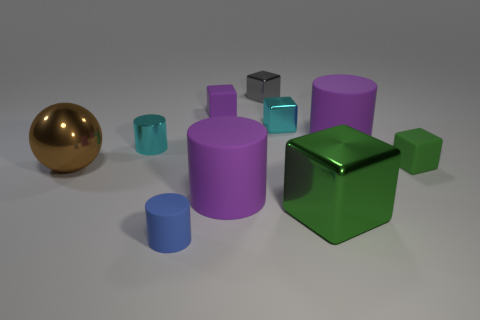How many rubber objects are purple cylinders or green blocks?
Ensure brevity in your answer.  3. Is the number of tiny cylinders in front of the tiny blue rubber object less than the number of purple matte things behind the tiny cyan metal block?
Your answer should be very brief. Yes. Is there a small object on the left side of the purple matte thing that is behind the big purple thing on the right side of the green shiny block?
Your response must be concise. Yes. What is the material of the block that is the same color as the metallic cylinder?
Provide a short and direct response. Metal. Does the cyan object that is on the right side of the tiny purple cube have the same shape as the large green metallic thing that is in front of the gray block?
Give a very brief answer. Yes. There is a cyan cylinder that is the same size as the cyan cube; what is its material?
Provide a short and direct response. Metal. Is the purple cylinder that is left of the gray shiny thing made of the same material as the green object behind the ball?
Offer a very short reply. Yes. The blue object that is the same size as the green rubber object is what shape?
Provide a succinct answer. Cylinder. What number of other objects are there of the same color as the shiny cylinder?
Make the answer very short. 1. What color is the small rubber object that is to the right of the gray cube?
Your response must be concise. Green. 